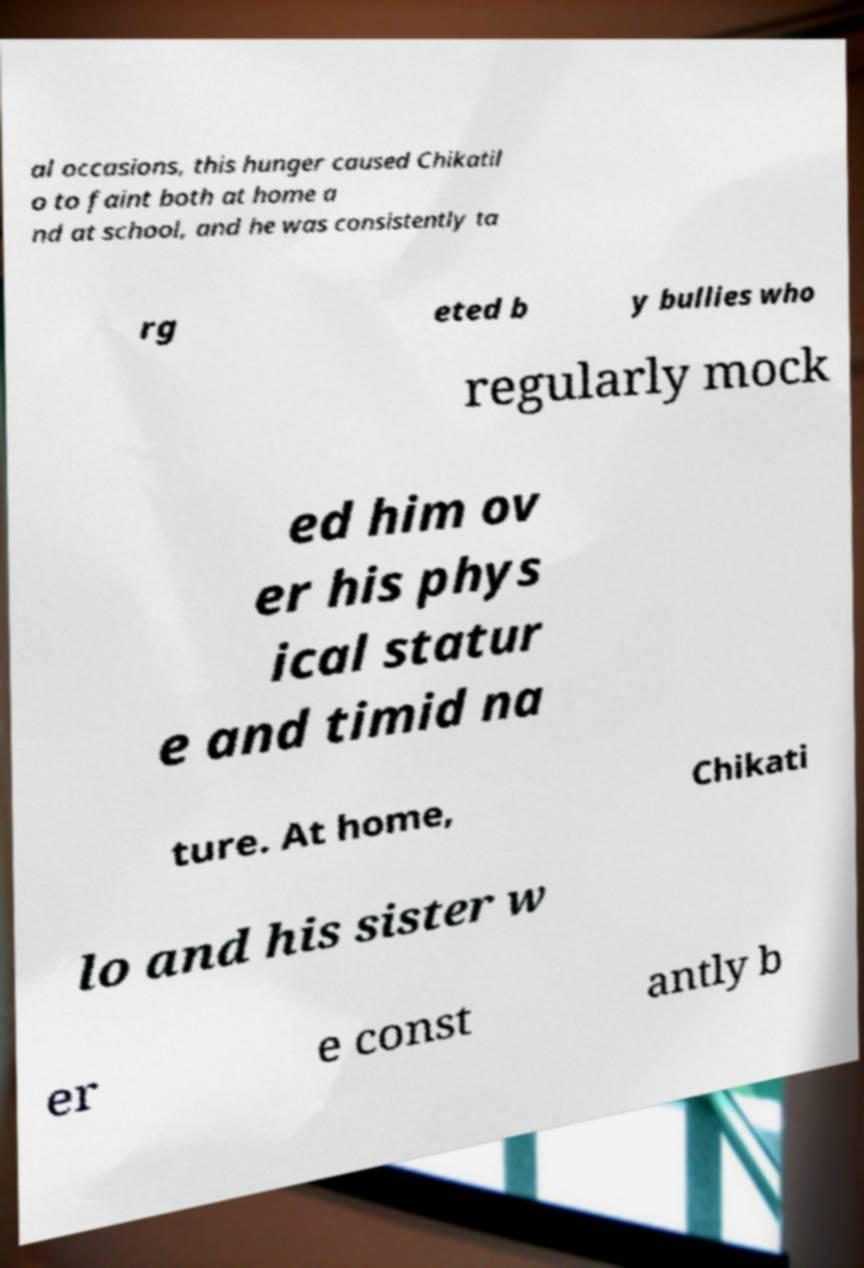Could you assist in decoding the text presented in this image and type it out clearly? al occasions, this hunger caused Chikatil o to faint both at home a nd at school, and he was consistently ta rg eted b y bullies who regularly mock ed him ov er his phys ical statur e and timid na ture. At home, Chikati lo and his sister w er e const antly b 